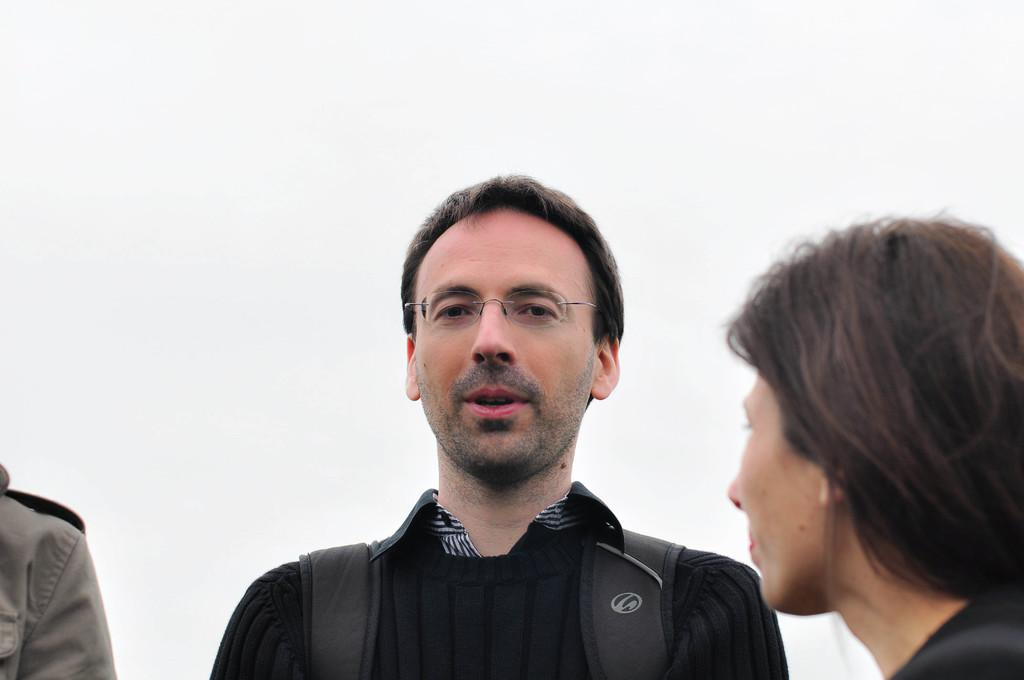How many people are in the image? There are two persons in the image. What can be seen in the background of the image? The background of the image is white. How many bells are hanging on the shelf in the image? There is no shelf or bells present in the image. 